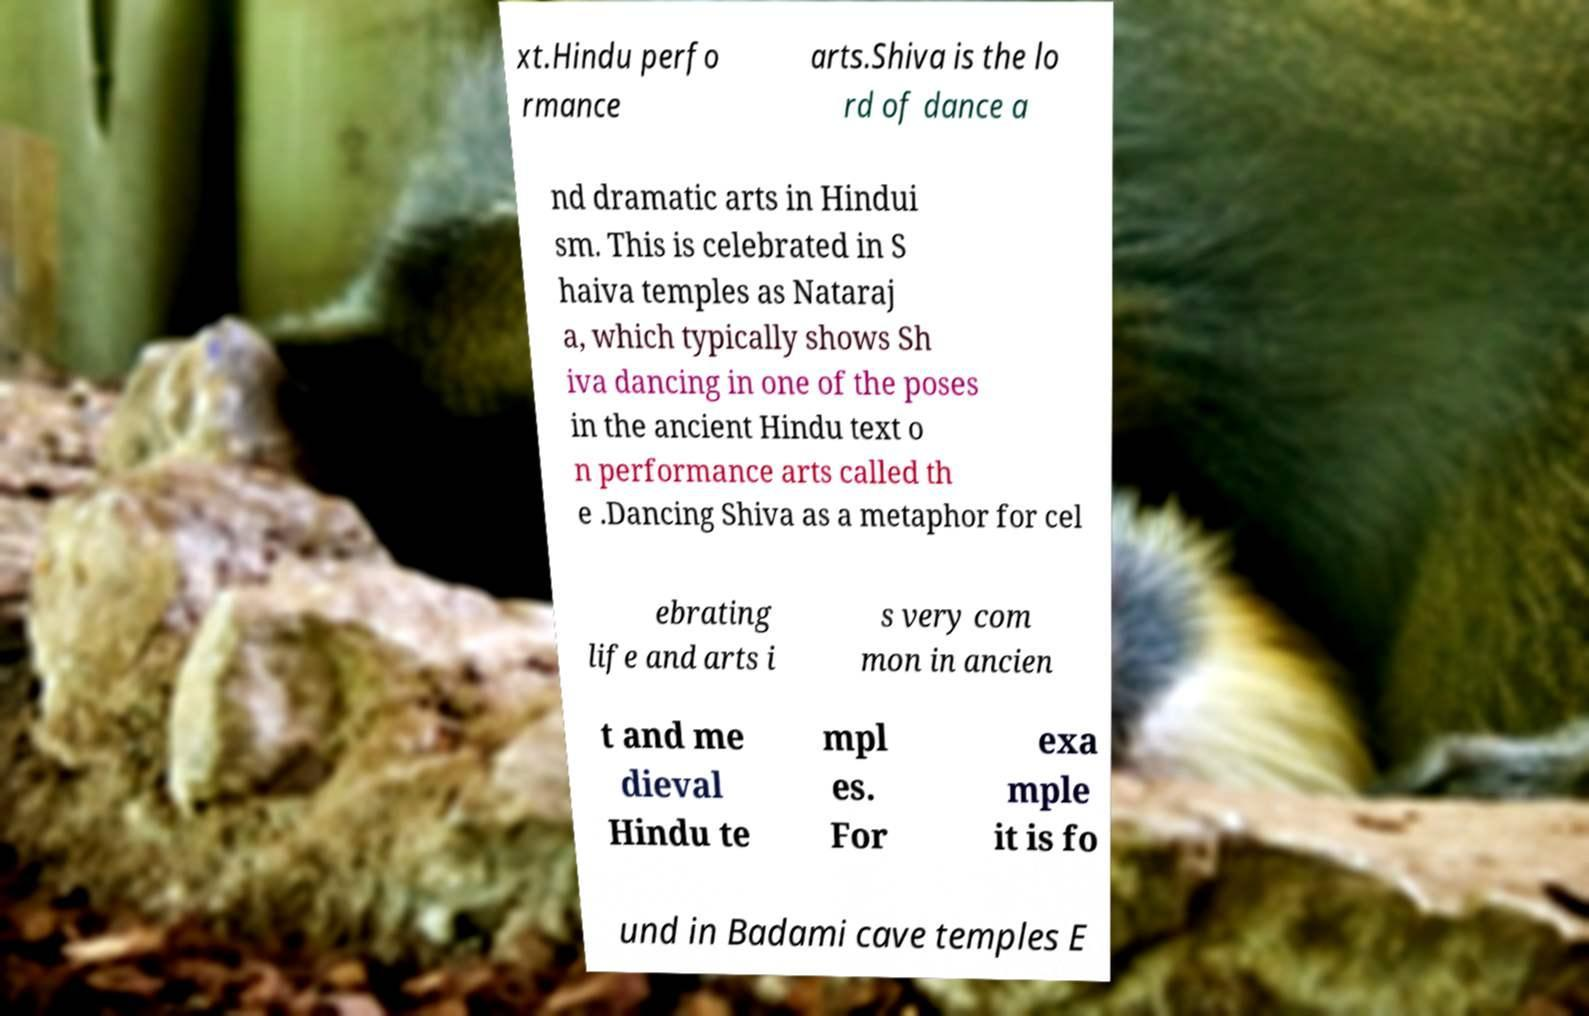I need the written content from this picture converted into text. Can you do that? xt.Hindu perfo rmance arts.Shiva is the lo rd of dance a nd dramatic arts in Hindui sm. This is celebrated in S haiva temples as Nataraj a, which typically shows Sh iva dancing in one of the poses in the ancient Hindu text o n performance arts called th e .Dancing Shiva as a metaphor for cel ebrating life and arts i s very com mon in ancien t and me dieval Hindu te mpl es. For exa mple it is fo und in Badami cave temples E 